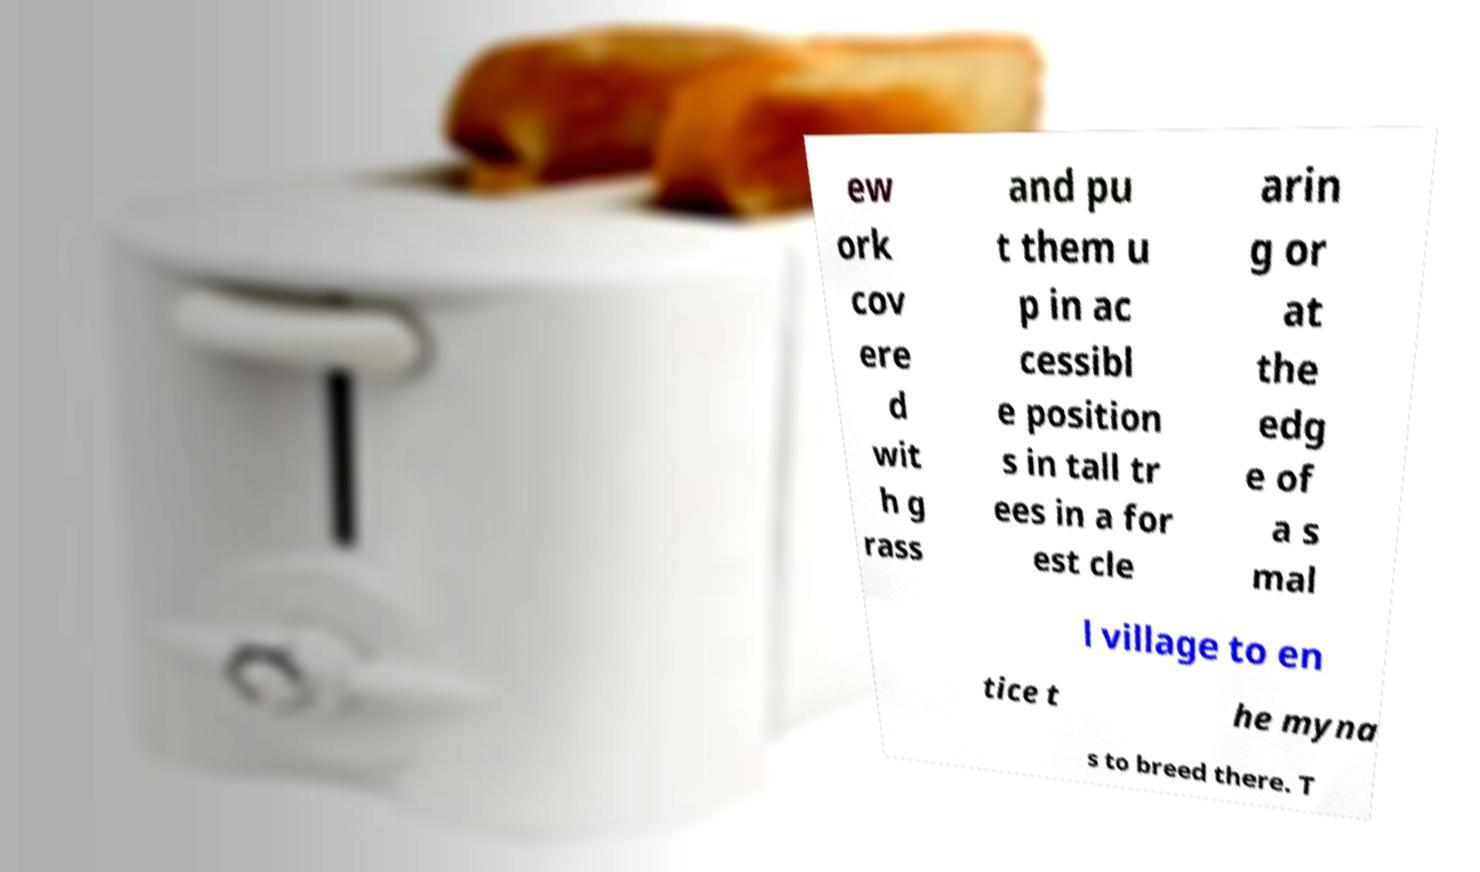Can you read and provide the text displayed in the image?This photo seems to have some interesting text. Can you extract and type it out for me? ew ork cov ere d wit h g rass and pu t them u p in ac cessibl e position s in tall tr ees in a for est cle arin g or at the edg e of a s mal l village to en tice t he myna s to breed there. T 